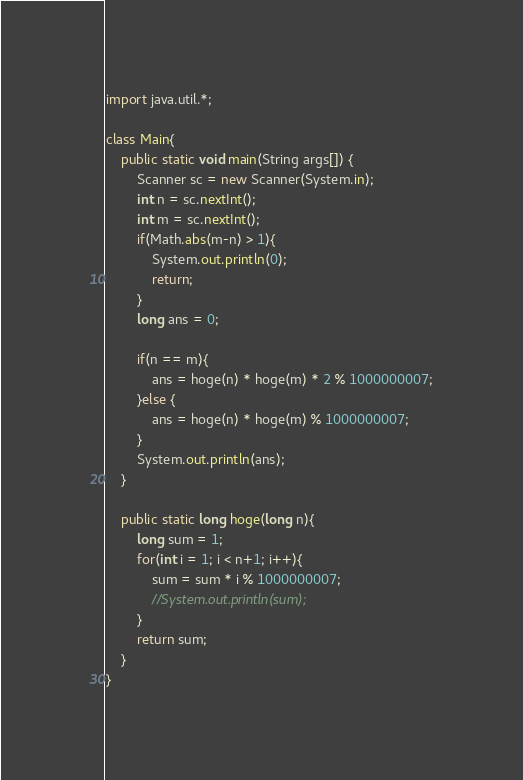<code> <loc_0><loc_0><loc_500><loc_500><_Java_>import java.util.*;

class Main{
    public static void main(String args[]) {
        Scanner sc = new Scanner(System.in);
        int n = sc.nextInt();
        int m = sc.nextInt();
        if(Math.abs(m-n) > 1){
            System.out.println(0);
            return;
        }
        long ans = 0;

        if(n == m){
            ans = hoge(n) * hoge(m) * 2 % 1000000007;
        }else {
            ans = hoge(n) * hoge(m) % 1000000007;
        }
        System.out.println(ans);
    }

    public static long hoge(long n){
        long sum = 1;
        for(int i = 1; i < n+1; i++){
            sum = sum * i % 1000000007;
            //System.out.println(sum);
        }
        return sum;
    }
}</code> 